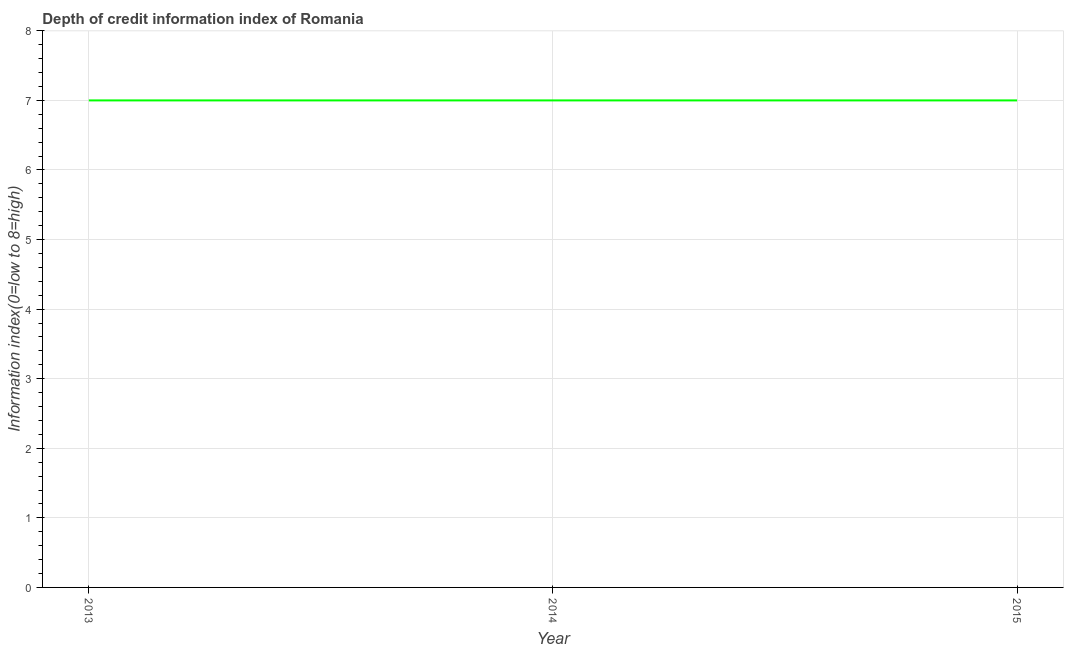What is the depth of credit information index in 2015?
Offer a very short reply. 7. Across all years, what is the maximum depth of credit information index?
Your answer should be compact. 7. Across all years, what is the minimum depth of credit information index?
Keep it short and to the point. 7. In which year was the depth of credit information index maximum?
Make the answer very short. 2013. What is the sum of the depth of credit information index?
Your answer should be very brief. 21. In how many years, is the depth of credit information index greater than 6.6 ?
Provide a succinct answer. 3. Do a majority of the years between 2013 and 2015 (inclusive) have depth of credit information index greater than 2.6 ?
Provide a succinct answer. Yes. What is the ratio of the depth of credit information index in 2014 to that in 2015?
Offer a very short reply. 1. Is the depth of credit information index in 2013 less than that in 2014?
Give a very brief answer. No. Is the difference between the depth of credit information index in 2014 and 2015 greater than the difference between any two years?
Give a very brief answer. Yes. What is the difference between the highest and the lowest depth of credit information index?
Offer a terse response. 0. Are the values on the major ticks of Y-axis written in scientific E-notation?
Your answer should be very brief. No. Does the graph contain grids?
Your answer should be very brief. Yes. What is the title of the graph?
Provide a succinct answer. Depth of credit information index of Romania. What is the label or title of the Y-axis?
Provide a succinct answer. Information index(0=low to 8=high). What is the difference between the Information index(0=low to 8=high) in 2013 and 2014?
Give a very brief answer. 0. What is the difference between the Information index(0=low to 8=high) in 2013 and 2015?
Make the answer very short. 0. 